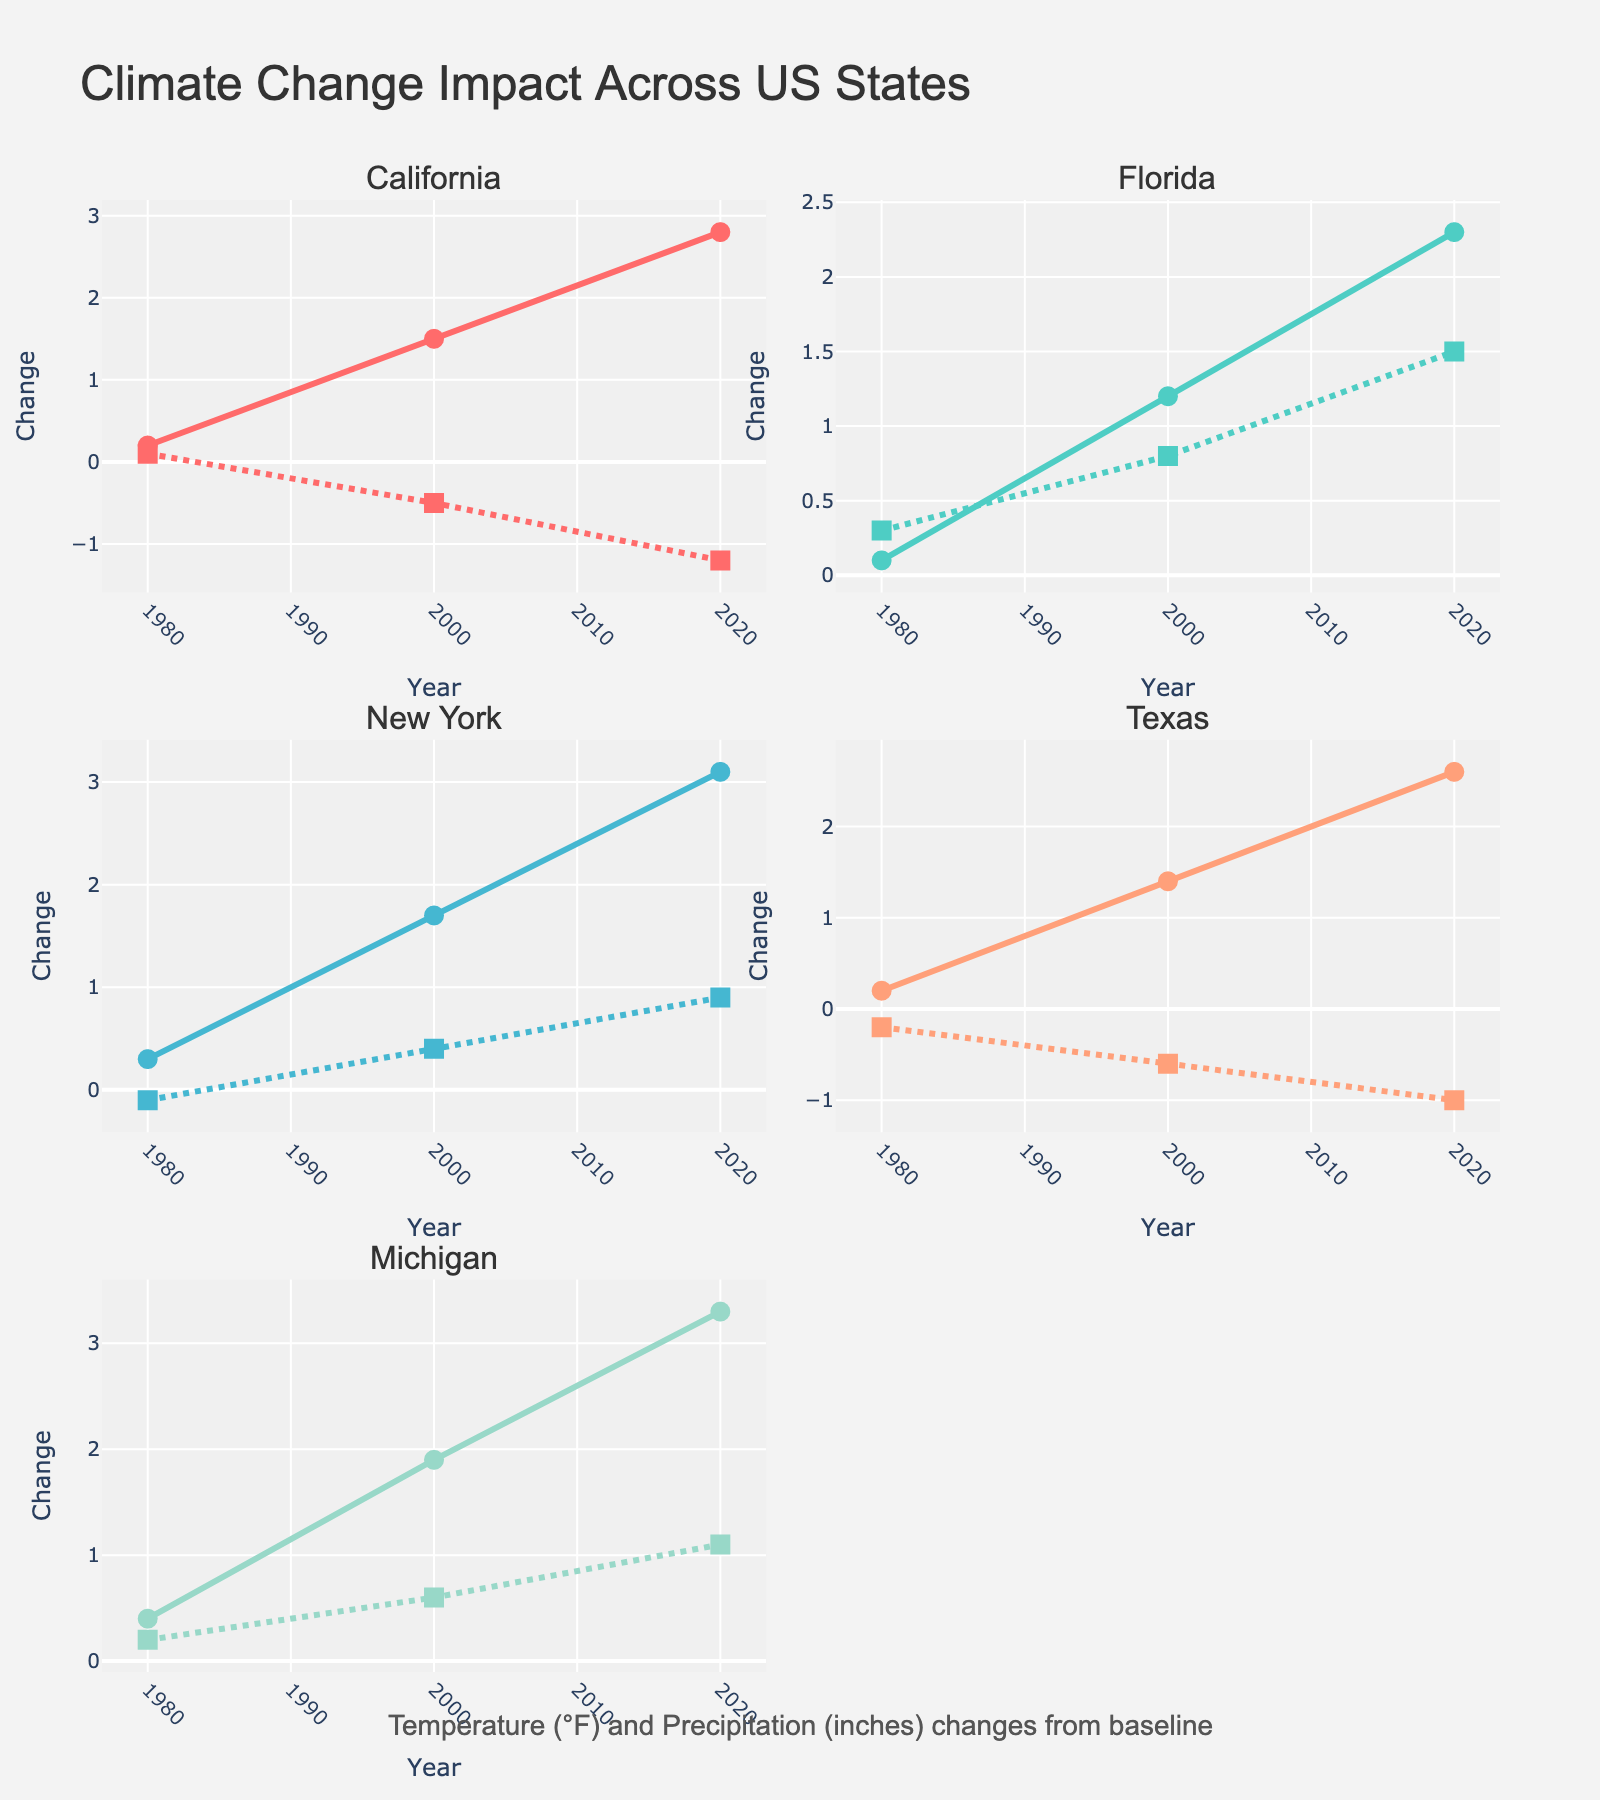What is the overall title of the grid of subplots? The overall title is centered at the top of the figure and says "Climate Change Impact Across US States."
Answer: Climate Change Impact Across US States What is the title of the subplot in the top-left corner? The subplot title is displayed at the top of each subplot. The one in the top-left corner is "California."
Answer: California Which state shows the largest increase in average temperature from 1980 to 2020? By looking at the slope and endpoints of the temperature lines, New York shows the largest increase from 0.3°F in 1980 to 3.1°F in 2020. So, the increase is 3.1 - 0.3 = 2.8°F.
Answer: New York How many states show a decreasing trend in precipitation change from 2000 to 2020? To find this, look at the precipitation lines from 2000 to 2020 for each state. California and Texas show a decreasing trend in precipitation over that period.
Answer: 2 Which state experienced the largest change in precipitation between 1980 and 2020? Look at the endpoints of the precipitation lines and compute the difference. California shows the largest change, with a decrease from 0.1 inches in 1980 to -1.2 inches in 2020, a change of -1.3 inches.
Answer: California Between Florida and Michigan, which has a greater average increase in temperature from 1980 to 2020? For Florida, the increase is 2.3 - 0.1 = 2.2°F. For Michigan, the increase is 3.3 - 0.4 = 2.9°F. Michigan has a greater average increase in temperature.
Answer: Michigan What year shows the maximum temperature change for New York? Two data points exist: 1.7°F in 2000 and 3.1°F in 2020. The maximum is 3.1°F, which is in the year 2020.
Answer: 2020 Is there a state where both temperature and precipitation increased between 2000 and 2020? Look for parallel increasing trends for both variables for any state. Florida and Michigan both show increasing trends for temperature and precipitation between 2000 and 2020.
Answer: Florida, Michigan 